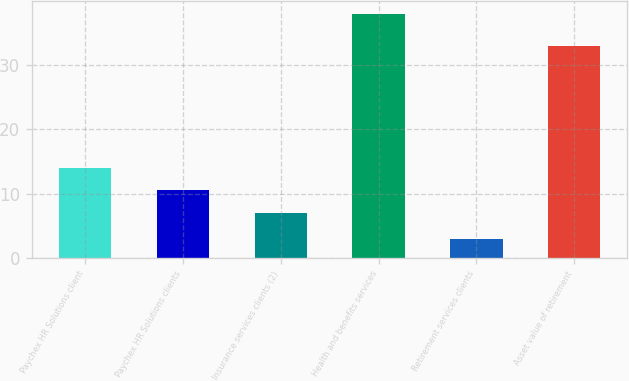<chart> <loc_0><loc_0><loc_500><loc_500><bar_chart><fcel>Paychex HR Solutions client<fcel>Paychex HR Solutions clients<fcel>Insurance services clients (2)<fcel>Health and benefits services<fcel>Retirement services clients<fcel>Asset value of retirement<nl><fcel>14<fcel>10.5<fcel>7<fcel>38<fcel>3<fcel>33<nl></chart> 